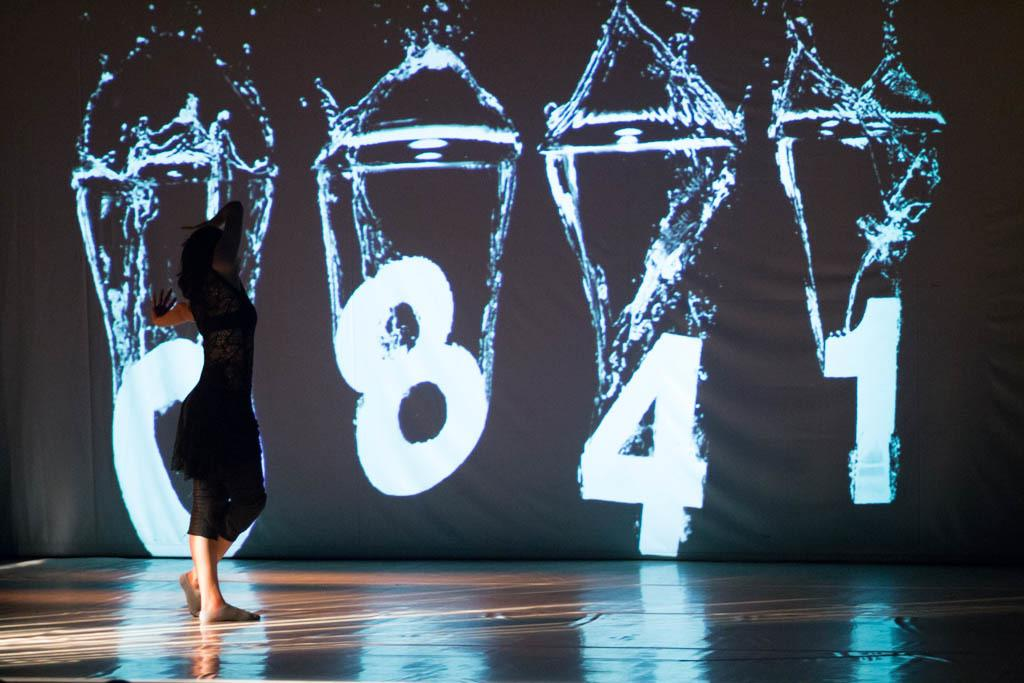What is the main feature of the image? There is a stage in the image. Who or what is on the stage? A person wearing a black dress is on the stage. How does the person on the stage look? The person is stunning. What can be seen in the background of the image? There is a huge screen in the background of the image. What type of jeans is the leaf wearing in the image? There is no leaf or jeans present in the image. 